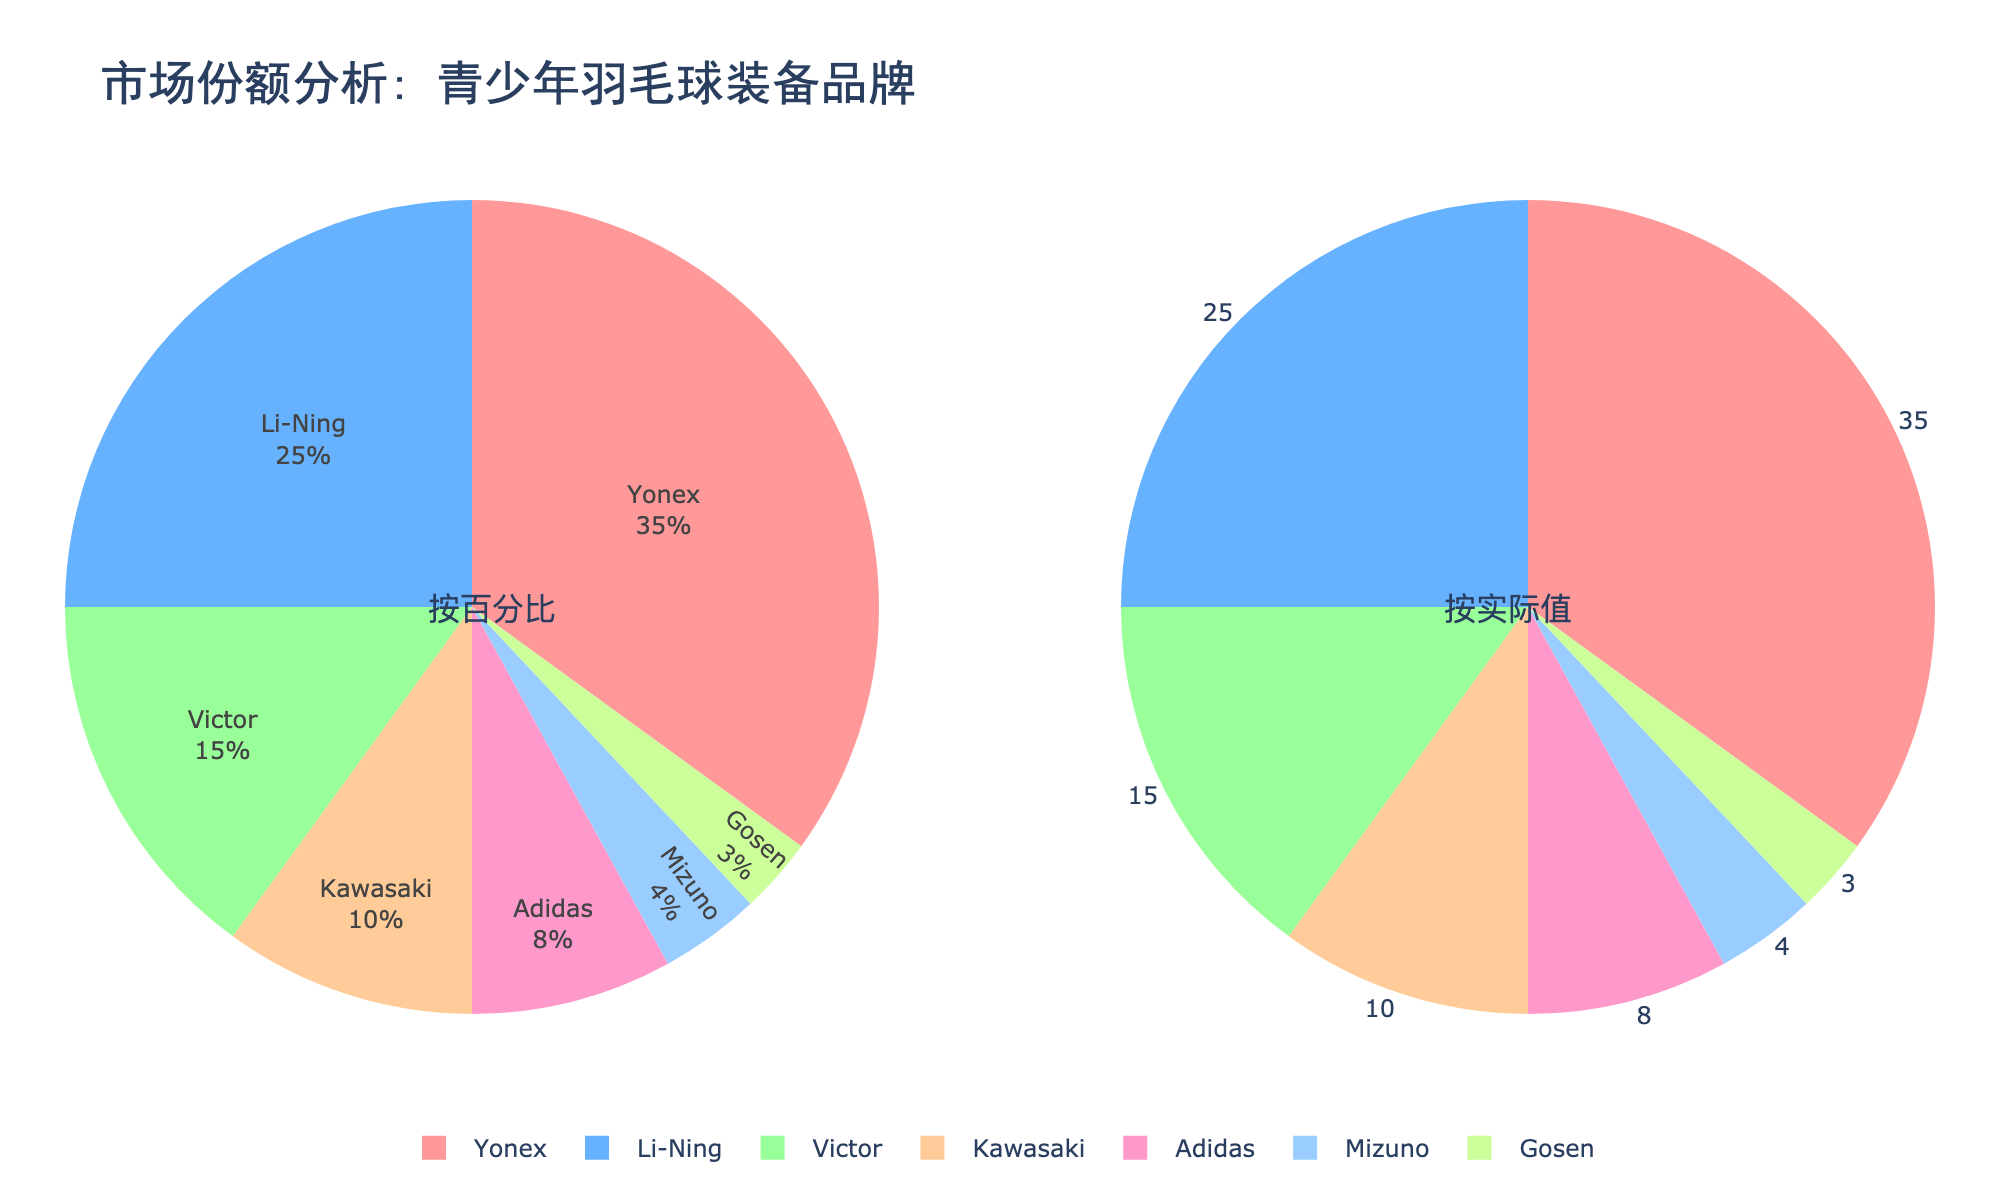What is the title of the figure? The title is located at the top of the figure and is written in large font size for easy visibility. It is centrally aligned.
Answer: 市场份额分析: 青少年羽毛球装备品牌 Which brand holds the largest market share among junior players? To find the brand with the largest market share, look for the largest segment in either of the pie charts. The label "Yonex" will have the largest portion.
Answer: Yonex How much market share does Adidas have? Check the pie charts for the segment labeled "Adidas." In the second pie chart, the value is displayed outside the segment.
Answer: 8 Which two brands together have a 40% market share? Combine the market shares of two brands that sum up to 40%. Yonex (35%) and Gosen (3%) sum up to 38%, which is not correct. Next try Yonex (35%) and Mizuno (4%) which is 39%, not correct as well. Try Yonex (35%) and Adidas (8%), that’s above 40%. Finally, Li-Ning (25%) and Victor (15%) sum to 40%.
Answer: Li-Ning and Victor What percentage of the market share does Kawasaki have? Locate the segment labeled "Kawasaki" on either pie chart, indicating its percentage share. It is 10%.
Answer: 10 Which brand has the second smallest market share and what is its value? Order the segments based on their sizes or values. After identifying Gosen with 3% as the smallest, Mizuno with 4% is the next smallest.
Answer: Mizuno, 4 What is the total market share held by Yonex, Li-Ning, and Victor combined? Add the market shares of Yonex (35%), Li-Ning (25%), and Victor (15%). Calculation: 35 + 25 + 15 = 75.
Answer: 75 Which brand has a bigger market share: Adidas or Kawasaki? Compare the segments for Adidas and Kawasaki. Adidas has 8%, while Kawasaki has 10%. Kawasaki is larger.
Answer: Kawasaki How many brands have a market share of at least 15%? Identify the segments with 15% or more market share: Yonex (35%), Li-Ning (25%), and Victor (15%). There are 3 brands.
Answer: 3 What is the difference in market share between the brand with the highest and the lowest market share? Subtract the smallest market share (Gosen, 3%) from the largest (Yonex, 35%). Calculation: 35 - 3 = 32.
Answer: 32 